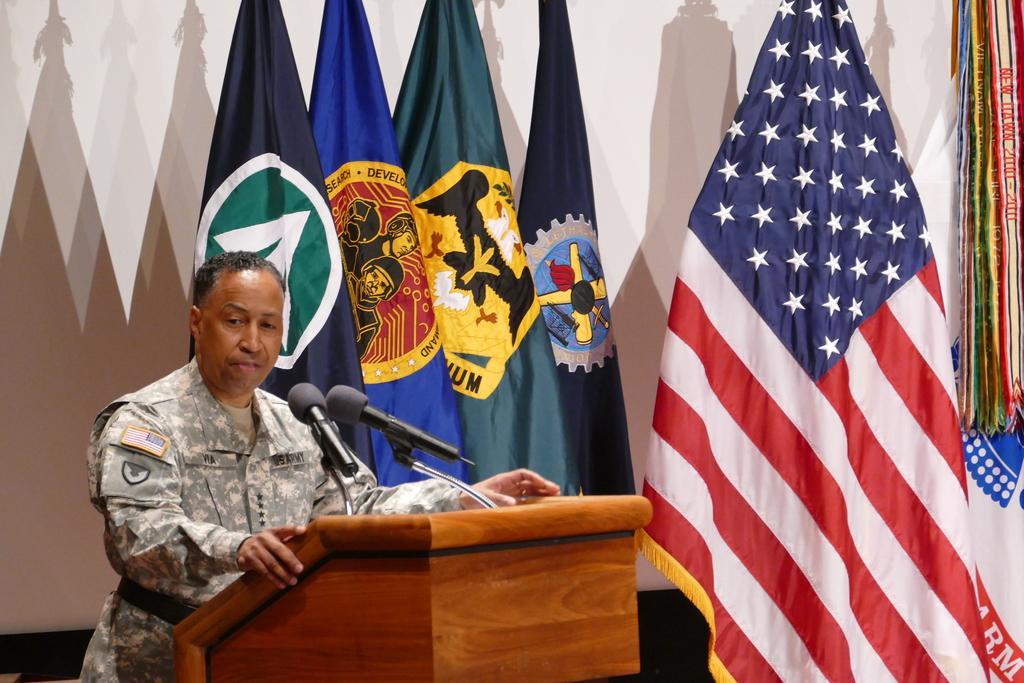How would you summarize this image in a sentence or two? In this picture we can see a man is standing in front of a podium, there are two microphones on the podium, on the left side there is a wall, we can see few flags in the background, there are shadows of flags on the wall. 